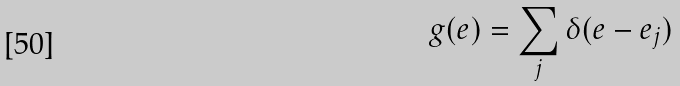Convert formula to latex. <formula><loc_0><loc_0><loc_500><loc_500>g ( e ) = \sum _ { j } \delta ( e - e _ { j } )</formula> 